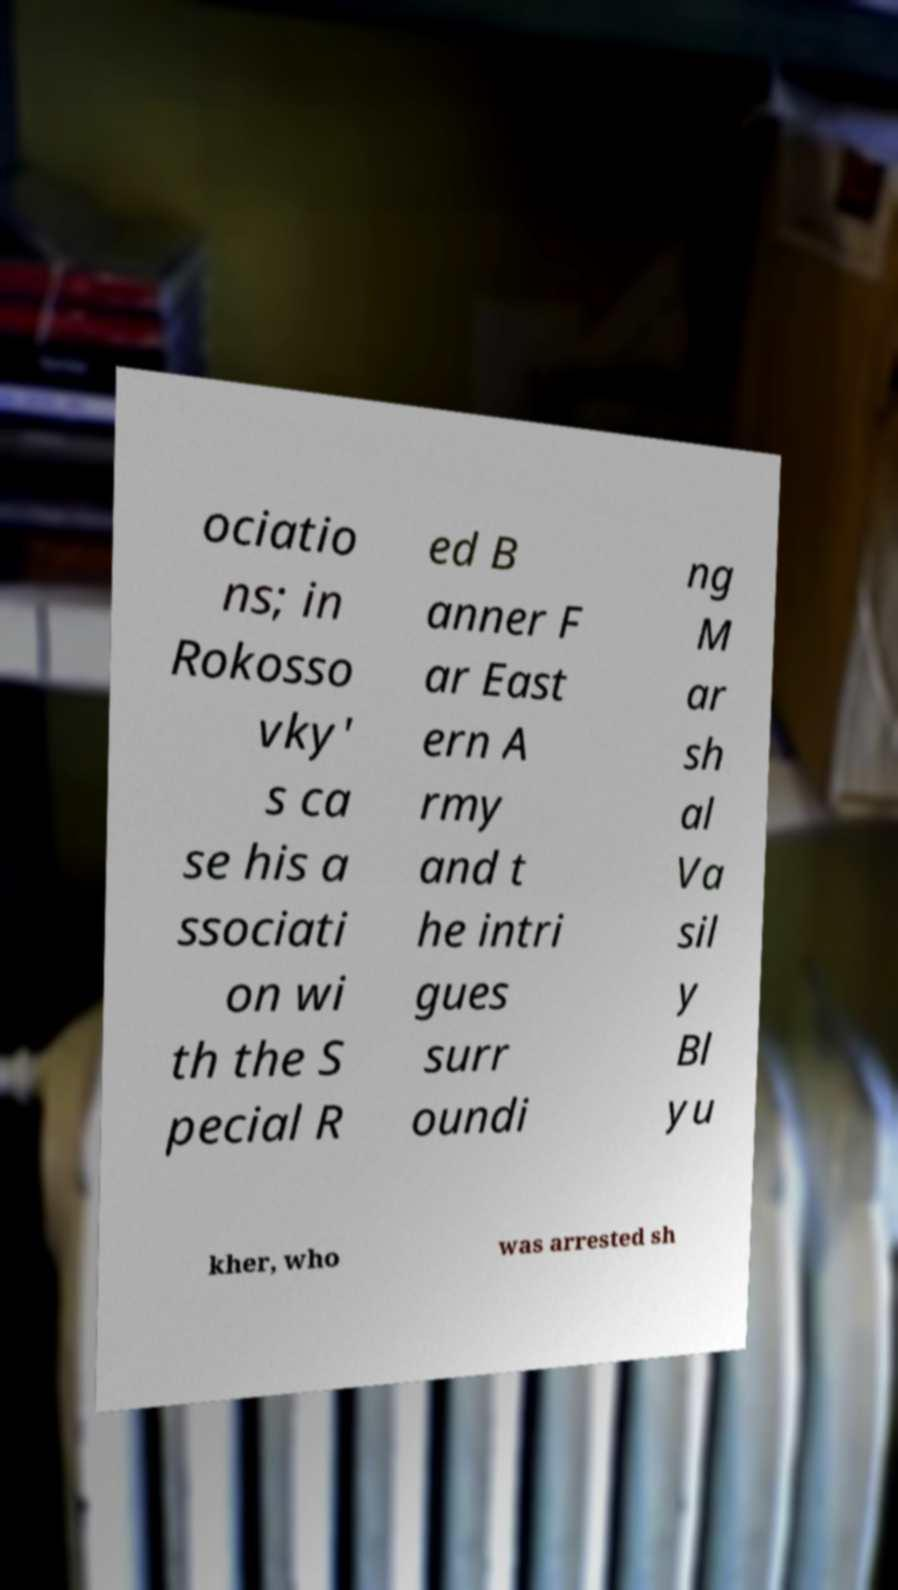Please identify and transcribe the text found in this image. ociatio ns; in Rokosso vky' s ca se his a ssociati on wi th the S pecial R ed B anner F ar East ern A rmy and t he intri gues surr oundi ng M ar sh al Va sil y Bl yu kher, who was arrested sh 